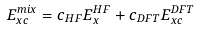Convert formula to latex. <formula><loc_0><loc_0><loc_500><loc_500>E _ { x c } ^ { m i x } = c _ { H F } E _ { x } ^ { H F } + c _ { D F T } E _ { x c } ^ { D F T }</formula> 